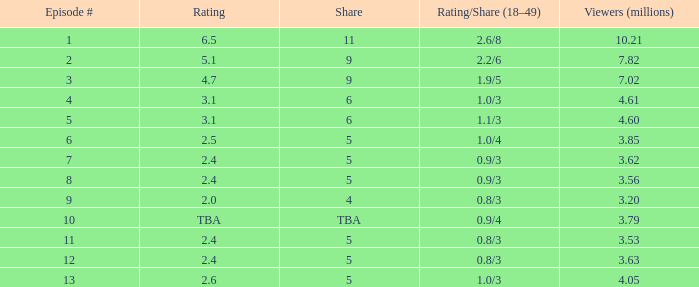9/4 and over None. 